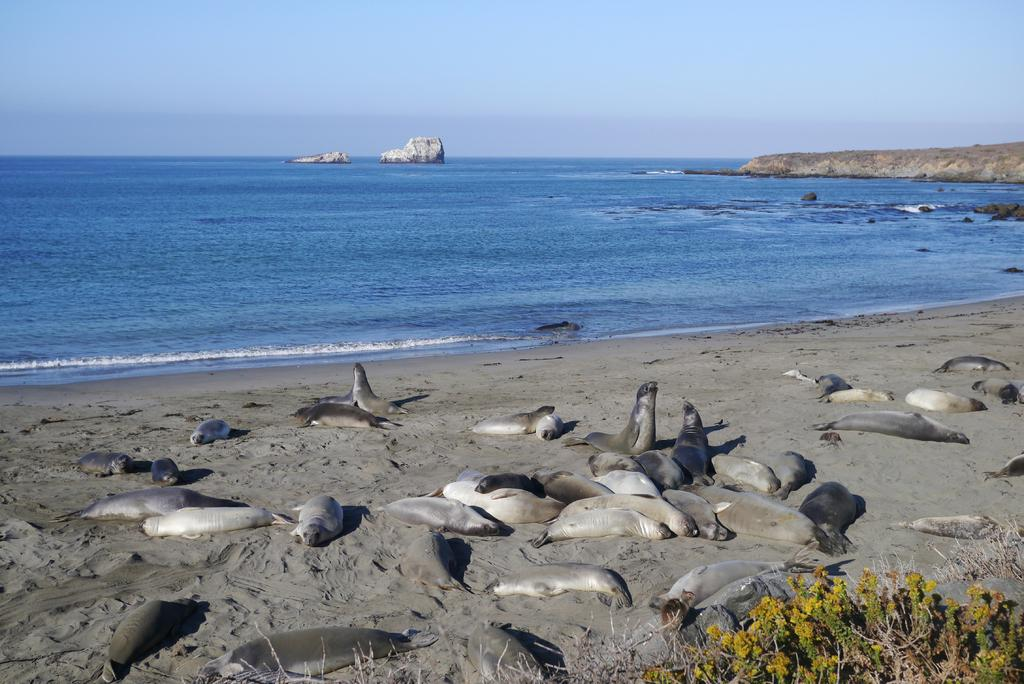What types of living organisms are present in the image? There are animals in the image. What colors are the animals? The animals are in cream and gray color. What other elements can be seen in the image besides the animals? There are plants, water, rocks, and the sky visible in the image. What color are the plants? The plants are in green color. What is the color of the sky in the image? The sky is blue in color. What type of power source is visible in the image? There is no power source visible in the image. Whose birthday is being celebrated in the image? There is no indication of a birthday celebration in the image. 